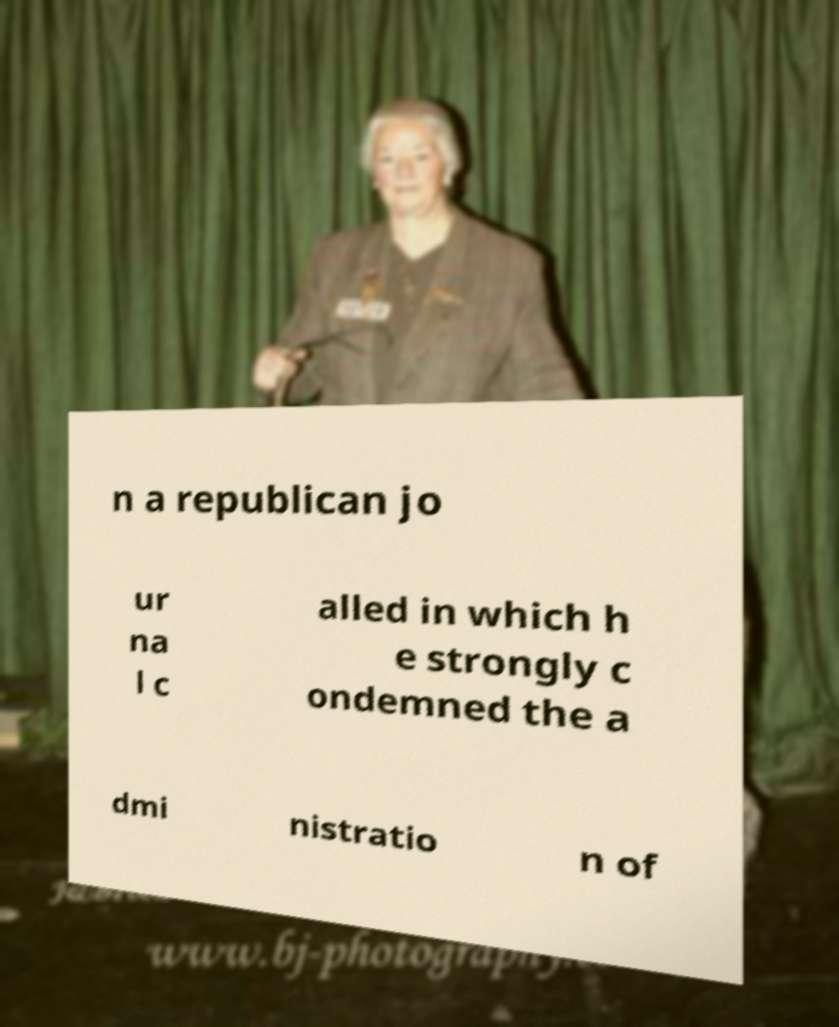I need the written content from this picture converted into text. Can you do that? n a republican jo ur na l c alled in which h e strongly c ondemned the a dmi nistratio n of 